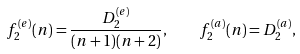Convert formula to latex. <formula><loc_0><loc_0><loc_500><loc_500>f _ { 2 } ^ { ( e ) } ( n ) = \frac { D _ { 2 } ^ { ( e ) } } { ( n + 1 ) ( n + 2 ) } , \quad f _ { 2 } ^ { ( a ) } ( n ) = D _ { 2 } ^ { ( a ) } ,</formula> 